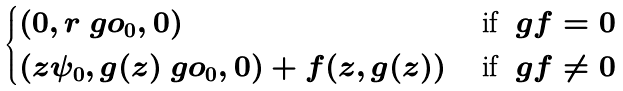<formula> <loc_0><loc_0><loc_500><loc_500>\begin{cases} ( 0 , r \ g o _ { 0 } , 0 ) & \text { if } \ g f = 0 \\ \left ( z \psi _ { 0 } , g ( z ) \ g o _ { 0 } , 0 \right ) + f ( z , g ( z ) ) & \text { if } \ g f \neq 0 \end{cases}</formula> 